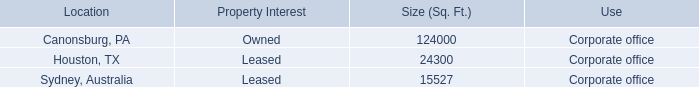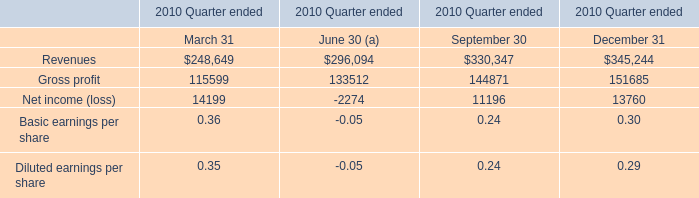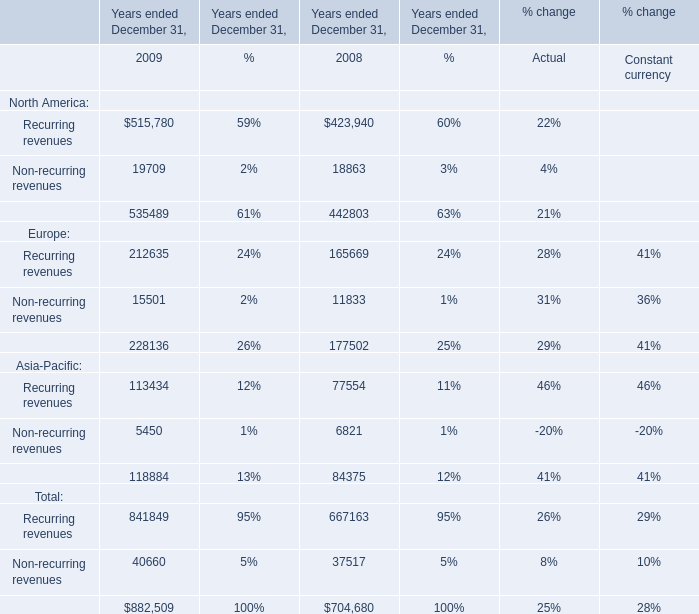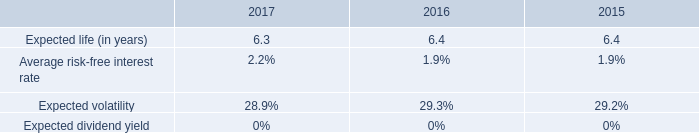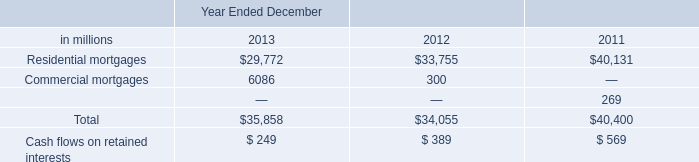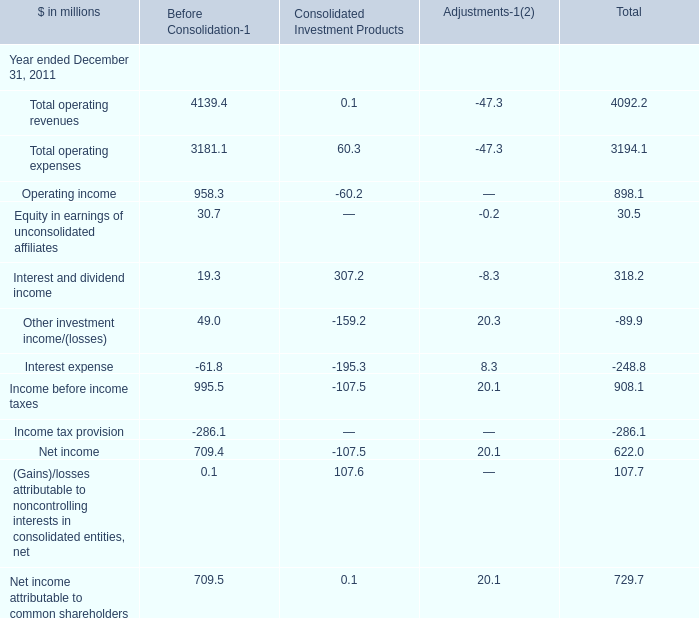What's the growth rate of Recurring revenues in 2009? (in %) 
Computations: ((515780 - 423940) / 423940)
Answer: 0.21663. 